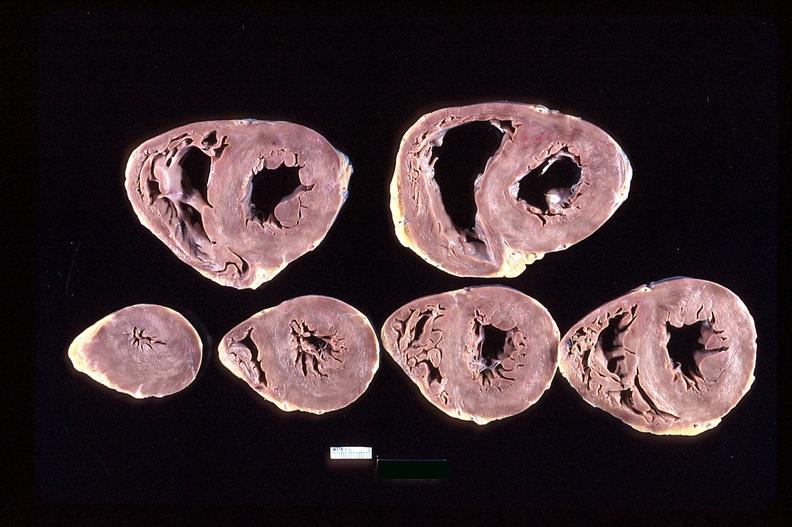s cardiovascular present?
Answer the question using a single word or phrase. Yes 